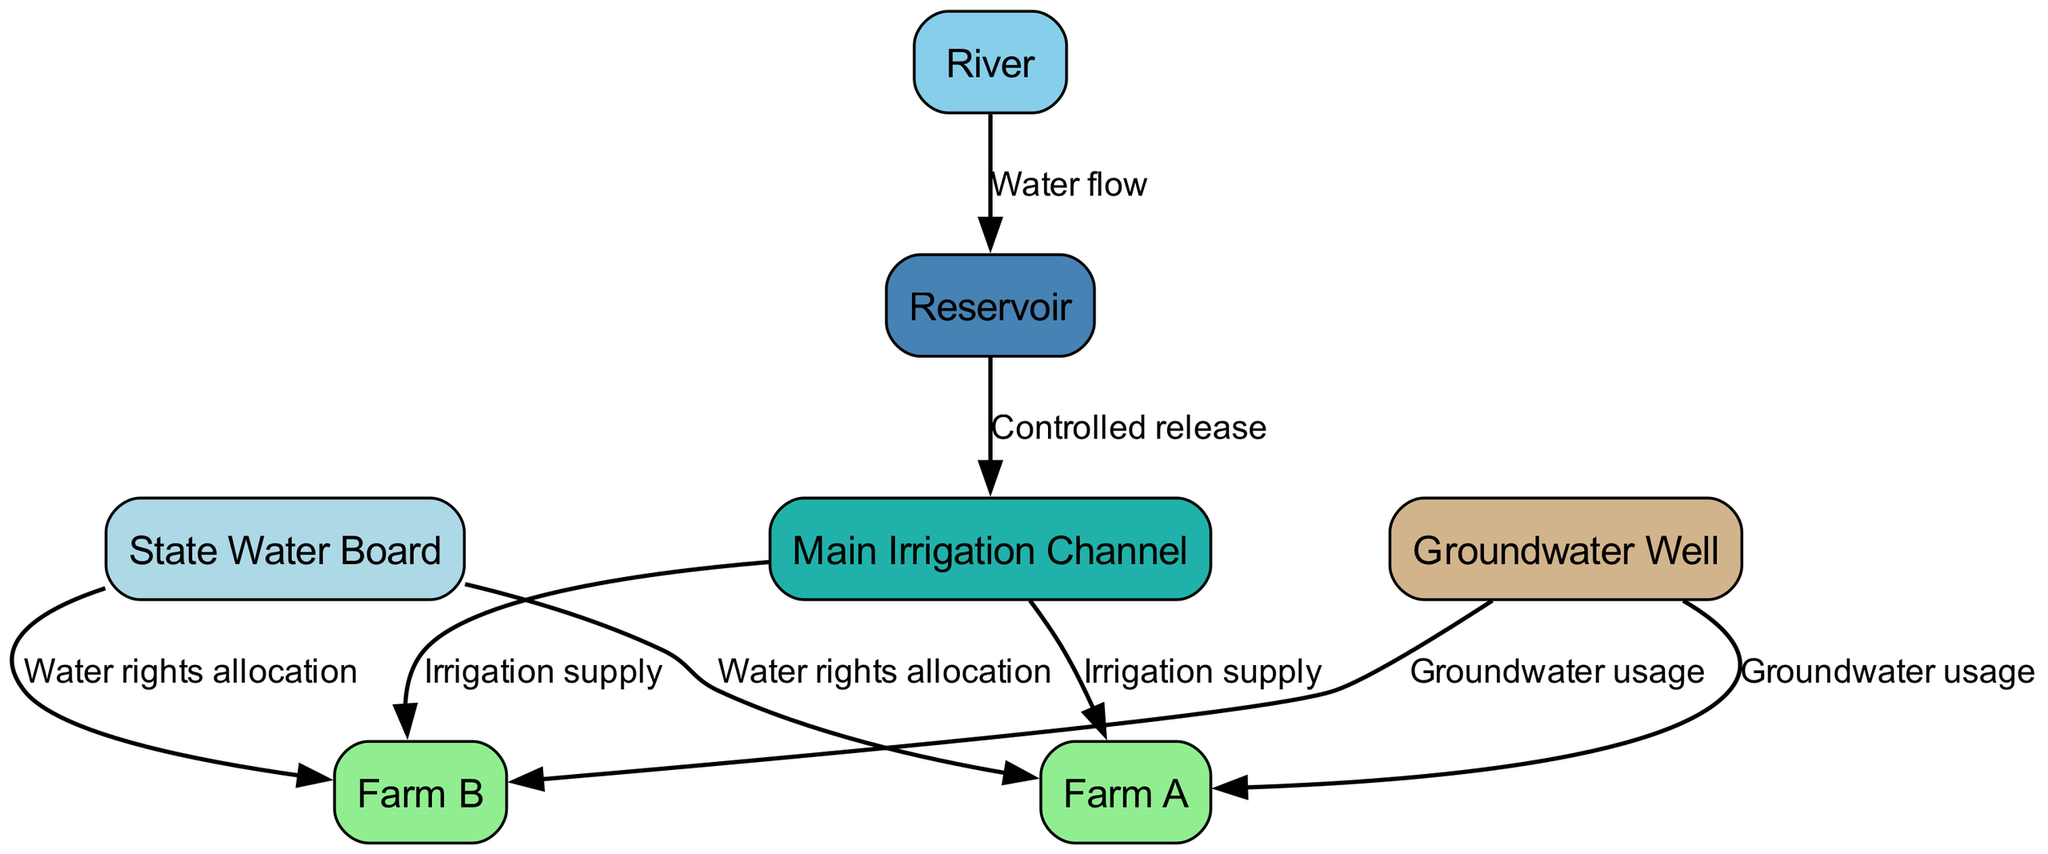What is the total number of nodes in the diagram? The diagram includes nodes representing the State Water Board, two farms, a groundwater well, a river, a reservoir, and a main irrigation channel. Counting these gives a total of seven nodes.
Answer: 7 What are the names of the two farms in the diagram? The diagram includes two nodes labeled as Farm A and Farm B. These are the names of the farms represented.
Answer: Farm A, Farm B What does the State Water Board allocate to Farm A? The diagram indicates that the State Water Board allocates water rights to Farm A as shown by the directed edge labeled "Water rights allocation" from the State Water Board to Farm A.
Answer: Water rights allocation How many sources of irrigation supply are identified for Farm B? Analyzing the diagram, Farm B receives irrigation supply from the main irrigation channel, as shown by an edge labeled "Irrigation supply." Thus, there is one source of irrigation supply identified for Farm B.
Answer: 1 What is the relationship between the River and the Reservoir in the diagram? The diagram shows a directed edge from the River to the Reservoir, labeled "Water flow," indicating that water flows from the river into the reservoir. This represents the relationship between the two components.
Answer: Water flow Which farms use groundwater according to the diagram? The edges from the groundwater well to both Farm A and Farm B are labeled "Groundwater usage," indicating that both farms utilize groundwater as part of their water rights allocation and irrigation.
Answer: Farm A, Farm B What is the function of the Main Irrigation Channel in the system? The diagram illustrates that water flows from the reservoir to the main irrigation channel indicated by the edge labeled "Controlled release," and subsequently to both Farm A and Farm B for irrigation purposes as denoted by the edges labeled "Irrigation supply." This establishes the main irrigation channel’s role in distributing water.
Answer: Irrigation supply How many edges connect the State Water Board to different farms? The diagram shows two edges from the State Water Board to the farms, one to Farm A and another to Farm B, both labeled "Water rights allocation." Thus, there are two connecting edges.
Answer: 2 What type of water source is the Groundwater Well classified as? In reviewing the diagram, the Groundwater Well is classified as a water source for both farms, indicated by edges labeled "Groundwater usage" connected to both Farm A and Farm B. This classification is clear from the edges connecting them.
Answer: Water source 